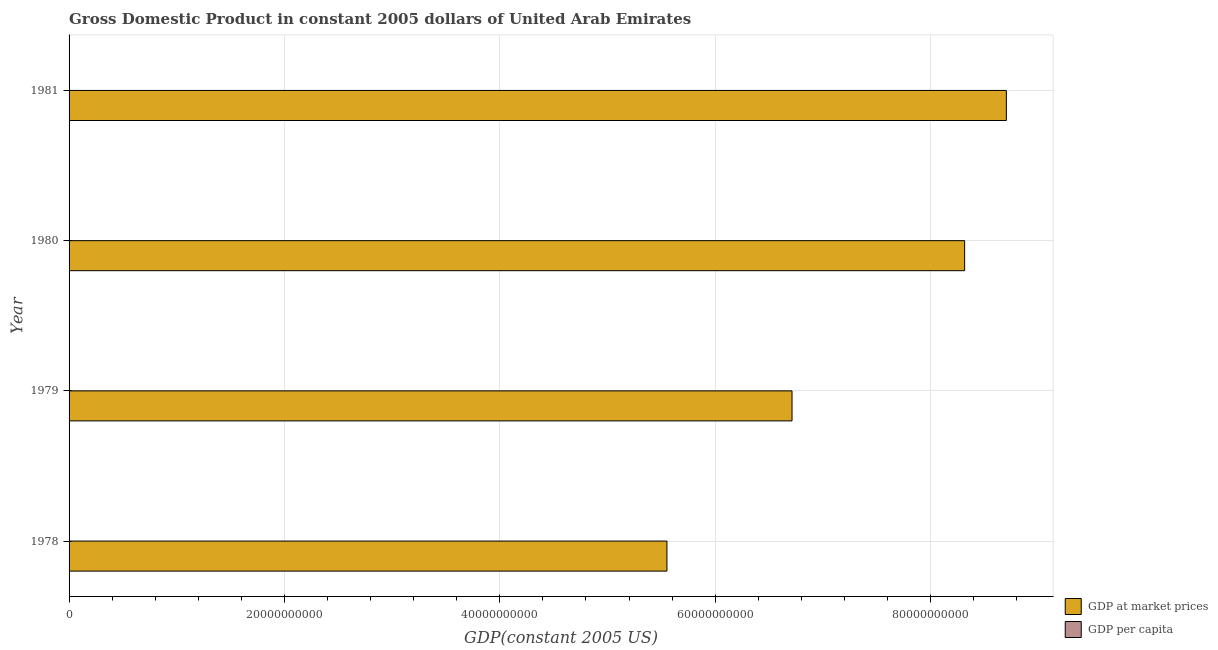How many different coloured bars are there?
Ensure brevity in your answer.  2. Are the number of bars per tick equal to the number of legend labels?
Keep it short and to the point. Yes. Are the number of bars on each tick of the Y-axis equal?
Keep it short and to the point. Yes. How many bars are there on the 1st tick from the top?
Your response must be concise. 2. What is the label of the 2nd group of bars from the top?
Your answer should be very brief. 1980. What is the gdp per capita in 1981?
Make the answer very short. 7.96e+04. Across all years, what is the maximum gdp per capita?
Offer a very short reply. 8.18e+04. Across all years, what is the minimum gdp at market prices?
Your response must be concise. 5.55e+1. In which year was the gdp at market prices minimum?
Offer a terse response. 1978. What is the total gdp per capita in the graph?
Your response must be concise. 3.01e+05. What is the difference between the gdp per capita in 1979 and that in 1981?
Offer a very short reply. -7226.16. What is the difference between the gdp at market prices in 1981 and the gdp per capita in 1980?
Your answer should be compact. 8.70e+1. What is the average gdp per capita per year?
Offer a very short reply. 7.52e+04. In the year 1978, what is the difference between the gdp per capita and gdp at market prices?
Make the answer very short. -5.55e+1. What is the ratio of the gdp at market prices in 1980 to that in 1981?
Provide a short and direct response. 0.95. Is the gdp at market prices in 1980 less than that in 1981?
Keep it short and to the point. Yes. Is the difference between the gdp at market prices in 1979 and 1981 greater than the difference between the gdp per capita in 1979 and 1981?
Ensure brevity in your answer.  No. What is the difference between the highest and the second highest gdp at market prices?
Your answer should be very brief. 3.87e+09. What is the difference between the highest and the lowest gdp per capita?
Keep it short and to the point. 1.47e+04. Is the sum of the gdp at market prices in 1978 and 1980 greater than the maximum gdp per capita across all years?
Your response must be concise. Yes. What does the 1st bar from the top in 1979 represents?
Your answer should be very brief. GDP per capita. What does the 1st bar from the bottom in 1981 represents?
Your response must be concise. GDP at market prices. Are all the bars in the graph horizontal?
Keep it short and to the point. Yes. How many years are there in the graph?
Keep it short and to the point. 4. What is the title of the graph?
Offer a very short reply. Gross Domestic Product in constant 2005 dollars of United Arab Emirates. Does "Forest land" appear as one of the legend labels in the graph?
Offer a terse response. No. What is the label or title of the X-axis?
Give a very brief answer. GDP(constant 2005 US). What is the label or title of the Y-axis?
Your answer should be very brief. Year. What is the GDP(constant 2005 US) in GDP at market prices in 1978?
Your answer should be very brief. 5.55e+1. What is the GDP(constant 2005 US) of GDP per capita in 1978?
Your response must be concise. 6.71e+04. What is the GDP(constant 2005 US) in GDP at market prices in 1979?
Your answer should be very brief. 6.71e+1. What is the GDP(constant 2005 US) of GDP per capita in 1979?
Provide a short and direct response. 7.24e+04. What is the GDP(constant 2005 US) of GDP at market prices in 1980?
Offer a very short reply. 8.32e+1. What is the GDP(constant 2005 US) of GDP per capita in 1980?
Keep it short and to the point. 8.18e+04. What is the GDP(constant 2005 US) of GDP at market prices in 1981?
Offer a very short reply. 8.70e+1. What is the GDP(constant 2005 US) of GDP per capita in 1981?
Your answer should be compact. 7.96e+04. Across all years, what is the maximum GDP(constant 2005 US) in GDP at market prices?
Your answer should be compact. 8.70e+1. Across all years, what is the maximum GDP(constant 2005 US) of GDP per capita?
Make the answer very short. 8.18e+04. Across all years, what is the minimum GDP(constant 2005 US) in GDP at market prices?
Provide a succinct answer. 5.55e+1. Across all years, what is the minimum GDP(constant 2005 US) of GDP per capita?
Provide a short and direct response. 6.71e+04. What is the total GDP(constant 2005 US) of GDP at market prices in the graph?
Give a very brief answer. 2.93e+11. What is the total GDP(constant 2005 US) in GDP per capita in the graph?
Keep it short and to the point. 3.01e+05. What is the difference between the GDP(constant 2005 US) of GDP at market prices in 1978 and that in 1979?
Provide a succinct answer. -1.16e+1. What is the difference between the GDP(constant 2005 US) of GDP per capita in 1978 and that in 1979?
Keep it short and to the point. -5297.56. What is the difference between the GDP(constant 2005 US) in GDP at market prices in 1978 and that in 1980?
Give a very brief answer. -2.76e+1. What is the difference between the GDP(constant 2005 US) in GDP per capita in 1978 and that in 1980?
Make the answer very short. -1.47e+04. What is the difference between the GDP(constant 2005 US) of GDP at market prices in 1978 and that in 1981?
Your answer should be compact. -3.15e+1. What is the difference between the GDP(constant 2005 US) of GDP per capita in 1978 and that in 1981?
Give a very brief answer. -1.25e+04. What is the difference between the GDP(constant 2005 US) of GDP at market prices in 1979 and that in 1980?
Offer a very short reply. -1.60e+1. What is the difference between the GDP(constant 2005 US) in GDP per capita in 1979 and that in 1980?
Give a very brief answer. -9391.89. What is the difference between the GDP(constant 2005 US) of GDP at market prices in 1979 and that in 1981?
Make the answer very short. -1.99e+1. What is the difference between the GDP(constant 2005 US) of GDP per capita in 1979 and that in 1981?
Offer a terse response. -7226.16. What is the difference between the GDP(constant 2005 US) in GDP at market prices in 1980 and that in 1981?
Keep it short and to the point. -3.87e+09. What is the difference between the GDP(constant 2005 US) of GDP per capita in 1980 and that in 1981?
Keep it short and to the point. 2165.73. What is the difference between the GDP(constant 2005 US) in GDP at market prices in 1978 and the GDP(constant 2005 US) in GDP per capita in 1979?
Provide a short and direct response. 5.55e+1. What is the difference between the GDP(constant 2005 US) in GDP at market prices in 1978 and the GDP(constant 2005 US) in GDP per capita in 1980?
Offer a terse response. 5.55e+1. What is the difference between the GDP(constant 2005 US) in GDP at market prices in 1978 and the GDP(constant 2005 US) in GDP per capita in 1981?
Provide a short and direct response. 5.55e+1. What is the difference between the GDP(constant 2005 US) in GDP at market prices in 1979 and the GDP(constant 2005 US) in GDP per capita in 1980?
Make the answer very short. 6.71e+1. What is the difference between the GDP(constant 2005 US) of GDP at market prices in 1979 and the GDP(constant 2005 US) of GDP per capita in 1981?
Give a very brief answer. 6.71e+1. What is the difference between the GDP(constant 2005 US) of GDP at market prices in 1980 and the GDP(constant 2005 US) of GDP per capita in 1981?
Give a very brief answer. 8.32e+1. What is the average GDP(constant 2005 US) of GDP at market prices per year?
Provide a short and direct response. 7.32e+1. What is the average GDP(constant 2005 US) of GDP per capita per year?
Your response must be concise. 7.52e+04. In the year 1978, what is the difference between the GDP(constant 2005 US) of GDP at market prices and GDP(constant 2005 US) of GDP per capita?
Make the answer very short. 5.55e+1. In the year 1979, what is the difference between the GDP(constant 2005 US) in GDP at market prices and GDP(constant 2005 US) in GDP per capita?
Your answer should be compact. 6.71e+1. In the year 1980, what is the difference between the GDP(constant 2005 US) in GDP at market prices and GDP(constant 2005 US) in GDP per capita?
Give a very brief answer. 8.32e+1. In the year 1981, what is the difference between the GDP(constant 2005 US) in GDP at market prices and GDP(constant 2005 US) in GDP per capita?
Provide a short and direct response. 8.70e+1. What is the ratio of the GDP(constant 2005 US) of GDP at market prices in 1978 to that in 1979?
Give a very brief answer. 0.83. What is the ratio of the GDP(constant 2005 US) of GDP per capita in 1978 to that in 1979?
Keep it short and to the point. 0.93. What is the ratio of the GDP(constant 2005 US) of GDP at market prices in 1978 to that in 1980?
Make the answer very short. 0.67. What is the ratio of the GDP(constant 2005 US) in GDP per capita in 1978 to that in 1980?
Ensure brevity in your answer.  0.82. What is the ratio of the GDP(constant 2005 US) in GDP at market prices in 1978 to that in 1981?
Make the answer very short. 0.64. What is the ratio of the GDP(constant 2005 US) in GDP per capita in 1978 to that in 1981?
Your response must be concise. 0.84. What is the ratio of the GDP(constant 2005 US) of GDP at market prices in 1979 to that in 1980?
Ensure brevity in your answer.  0.81. What is the ratio of the GDP(constant 2005 US) of GDP per capita in 1979 to that in 1980?
Offer a very short reply. 0.89. What is the ratio of the GDP(constant 2005 US) in GDP at market prices in 1979 to that in 1981?
Your answer should be compact. 0.77. What is the ratio of the GDP(constant 2005 US) in GDP per capita in 1979 to that in 1981?
Your response must be concise. 0.91. What is the ratio of the GDP(constant 2005 US) in GDP at market prices in 1980 to that in 1981?
Provide a succinct answer. 0.96. What is the ratio of the GDP(constant 2005 US) of GDP per capita in 1980 to that in 1981?
Provide a succinct answer. 1.03. What is the difference between the highest and the second highest GDP(constant 2005 US) in GDP at market prices?
Give a very brief answer. 3.87e+09. What is the difference between the highest and the second highest GDP(constant 2005 US) in GDP per capita?
Give a very brief answer. 2165.73. What is the difference between the highest and the lowest GDP(constant 2005 US) of GDP at market prices?
Offer a terse response. 3.15e+1. What is the difference between the highest and the lowest GDP(constant 2005 US) in GDP per capita?
Offer a terse response. 1.47e+04. 